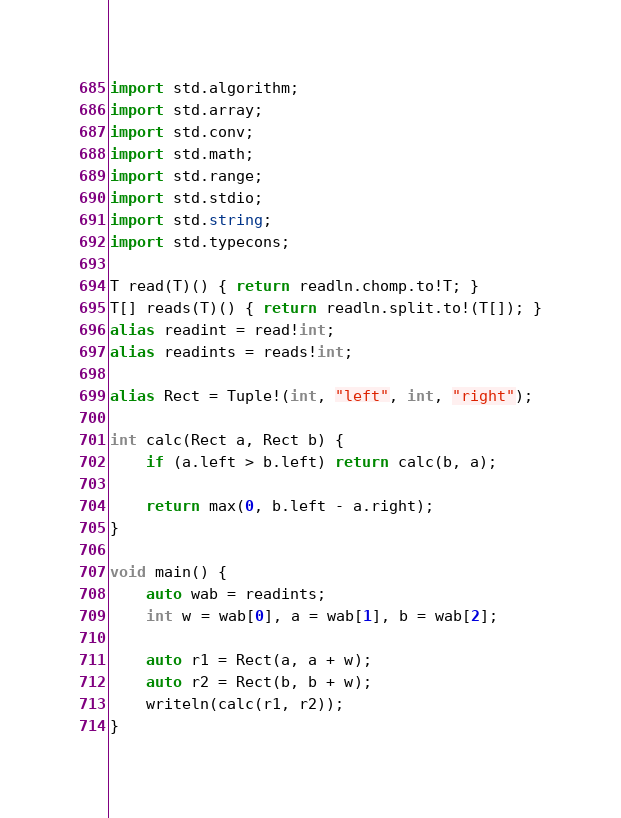Convert code to text. <code><loc_0><loc_0><loc_500><loc_500><_D_>import std.algorithm;
import std.array;
import std.conv;
import std.math;
import std.range;
import std.stdio;
import std.string;
import std.typecons;

T read(T)() { return readln.chomp.to!T; }
T[] reads(T)() { return readln.split.to!(T[]); }
alias readint = read!int;
alias readints = reads!int;

alias Rect = Tuple!(int, "left", int, "right");

int calc(Rect a, Rect b) {
    if (a.left > b.left) return calc(b, a);

    return max(0, b.left - a.right);
}

void main() {
    auto wab = readints;
    int w = wab[0], a = wab[1], b = wab[2];

    auto r1 = Rect(a, a + w);
    auto r2 = Rect(b, b + w);
    writeln(calc(r1, r2));
}
</code> 